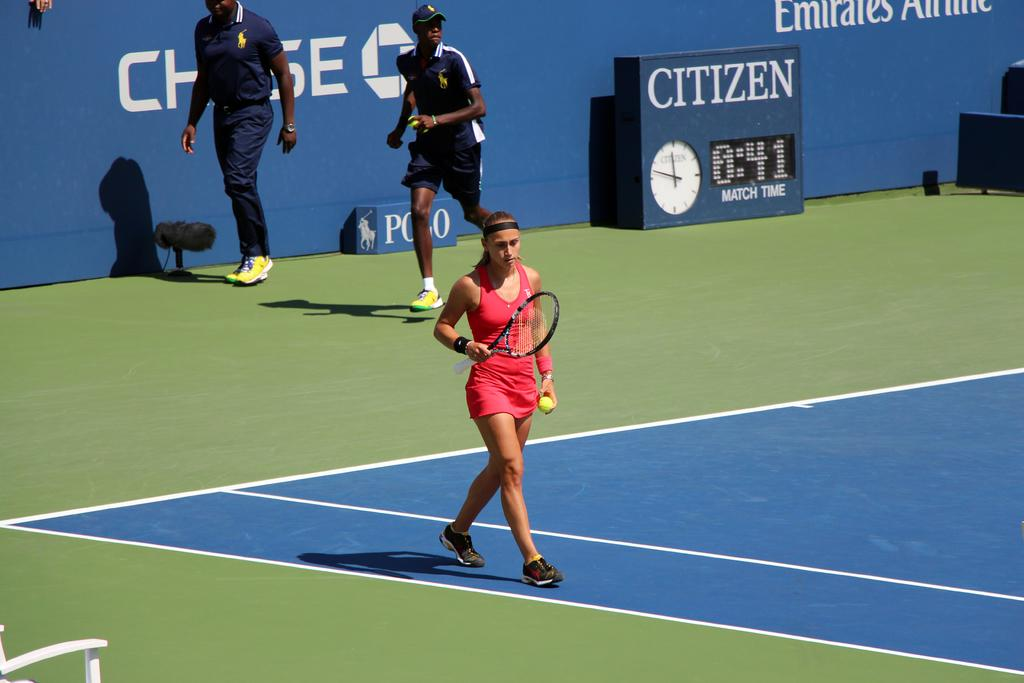How many people are present in the image? There are three people in the image. What is the woman holding in her hand? The woman is holding a ball and shuttle bat in her hand. What are the other two people doing in the image? Two people are running on the ground. What type of business is being conducted in the image? There is no indication of any business being conducted in the image. 